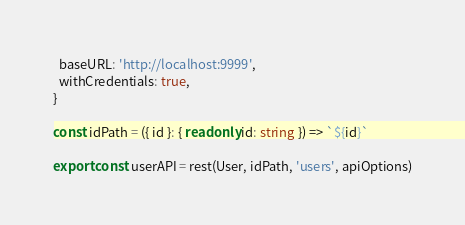<code> <loc_0><loc_0><loc_500><loc_500><_TypeScript_>  baseURL: 'http://localhost:9999',
  withCredentials: true,
}

const idPath = ({ id }: { readonly id: string }) => `${id}`

export const userAPI = rest(User, idPath, 'users', apiOptions)
</code> 